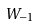<formula> <loc_0><loc_0><loc_500><loc_500>W _ { - 1 }</formula> 